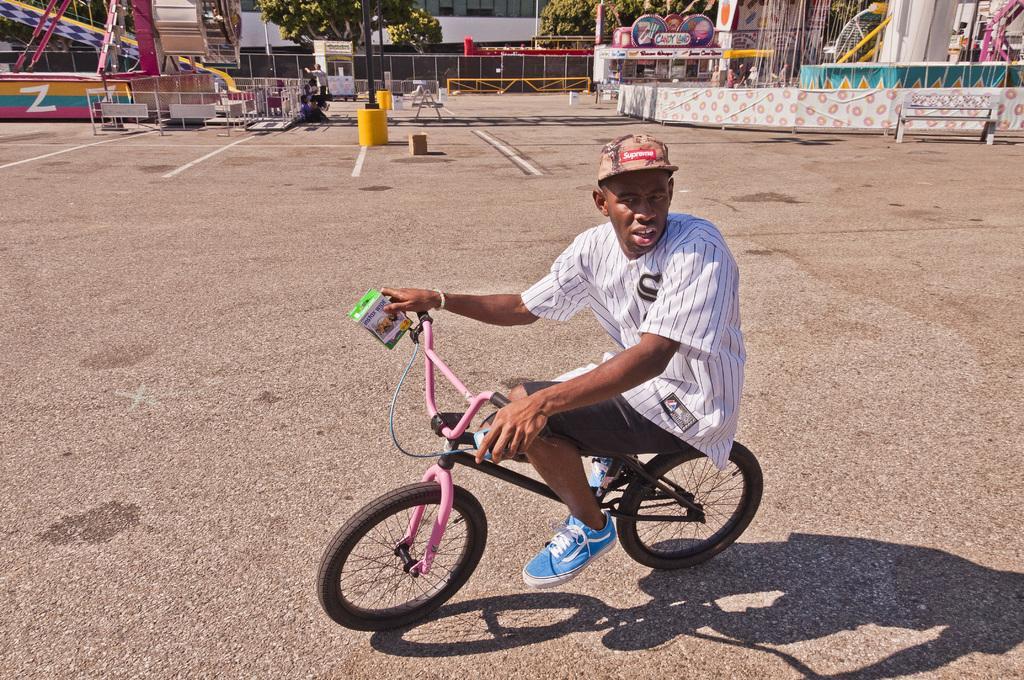Describe this image in one or two sentences. In this image we can see a man is cycling. He is wearing white color shirt with shorts and holding green color box in his hand. Background of the image we can see fencing, bench, pole, trees, ride and glass windows. 